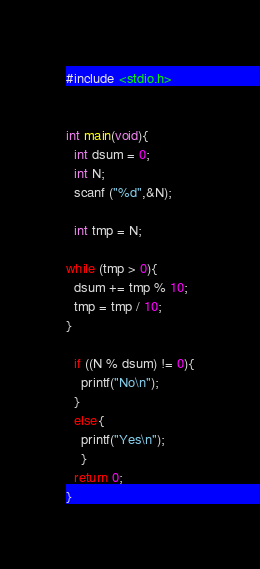Convert code to text. <code><loc_0><loc_0><loc_500><loc_500><_C_>#include <stdio.h>
 
 
int main(void){
  int dsum = 0;
  int N;
  scanf ("%d",&N);
 
  int tmp = N;
 
while (tmp > 0){
  dsum += tmp % 10;
  tmp = tmp / 10;
}
 
  if ((N % dsum) != 0){
    printf("No\n");
  }
  else{
    printf("Yes\n");
    }
  return 0;
}</code> 